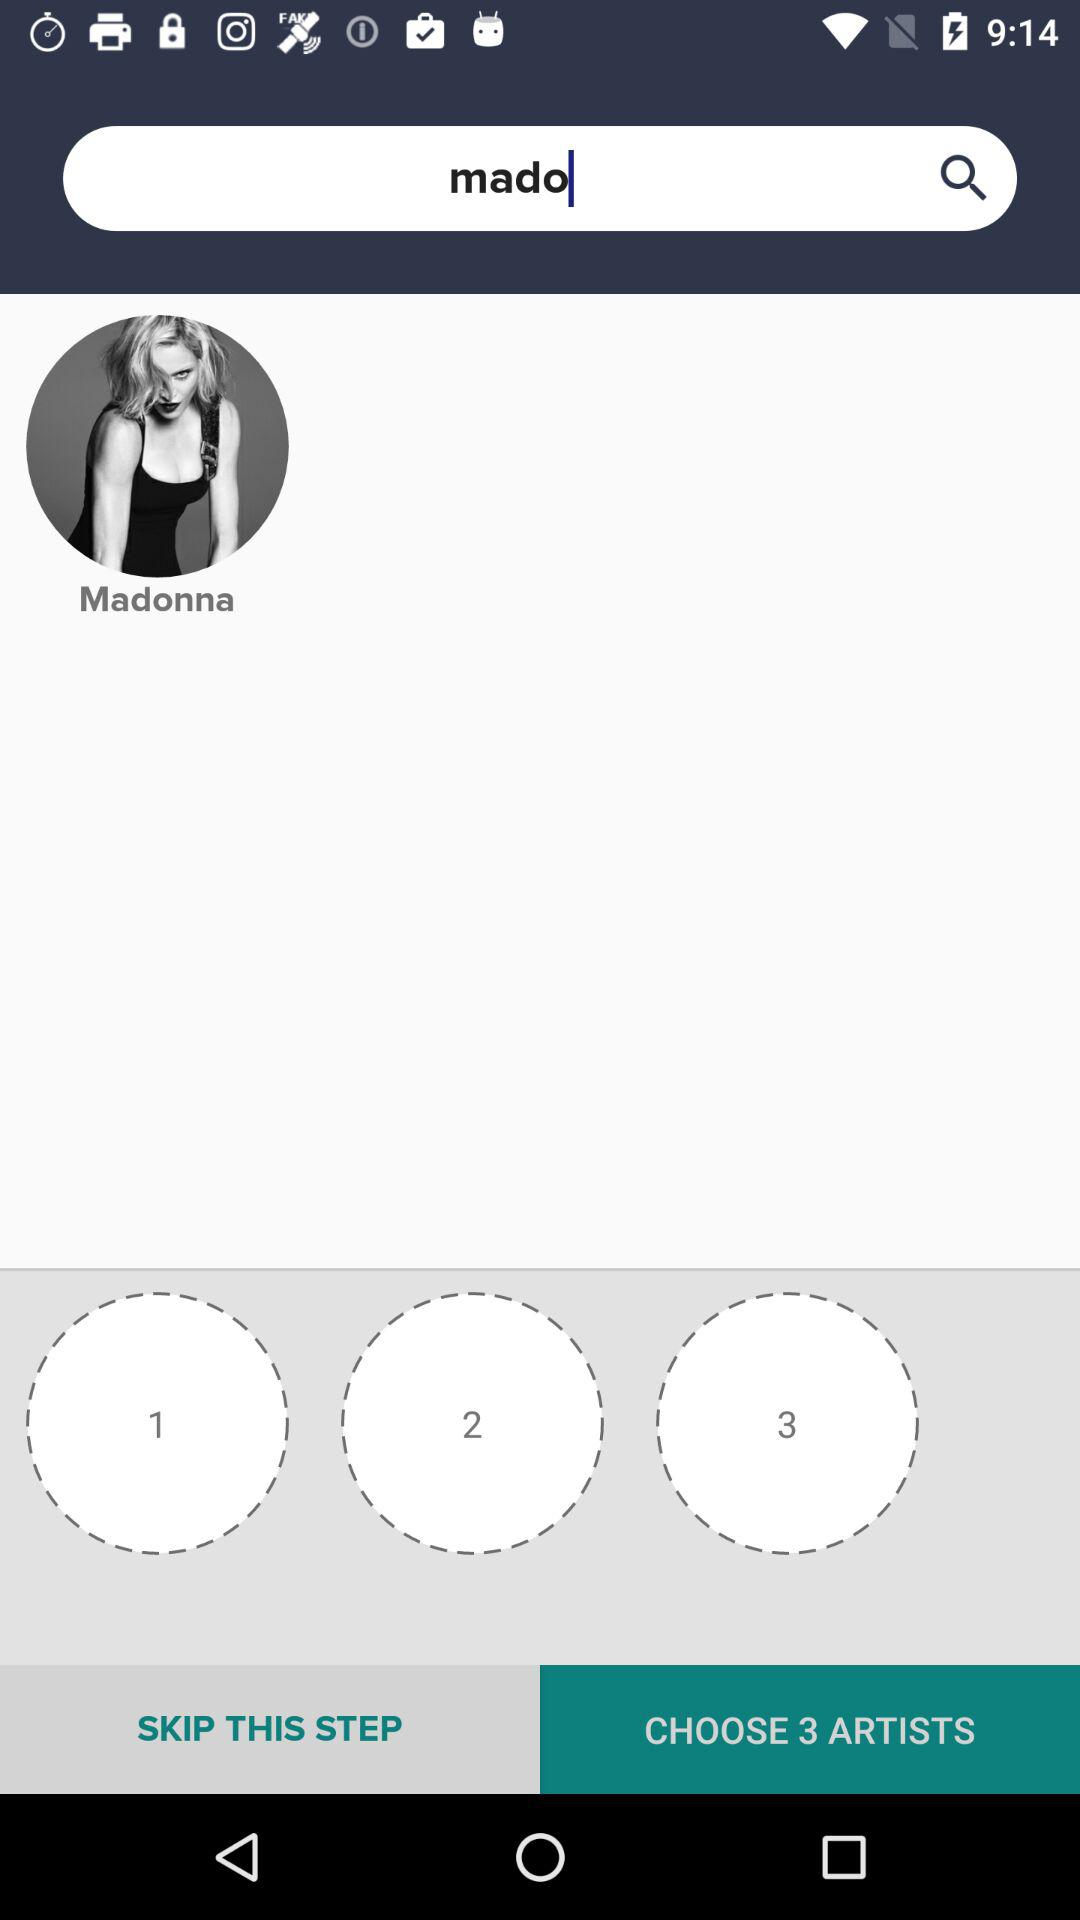What is written in the search bar? In the search box, "mado" is written. 